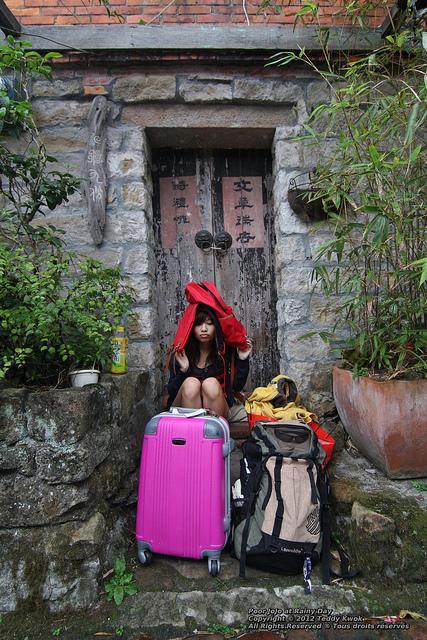How many backpacks are there?
Give a very brief answer. 2. How many potted plants can you see?
Give a very brief answer. 2. 